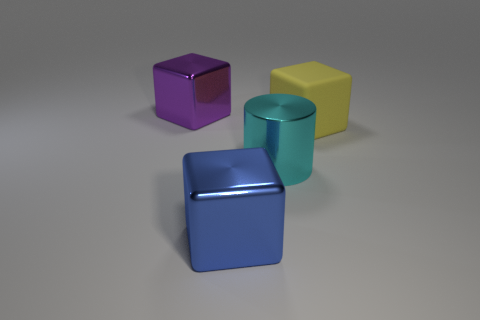Subtract all big shiny blocks. How many blocks are left? 1 Add 4 red cylinders. How many objects exist? 8 Subtract all blue cubes. How many cubes are left? 2 Subtract all cylinders. How many objects are left? 3 Add 1 cyan cylinders. How many cyan cylinders exist? 2 Subtract 0 cyan spheres. How many objects are left? 4 Subtract all green cubes. Subtract all green balls. How many cubes are left? 3 Subtract all yellow blocks. Subtract all large cyan cylinders. How many objects are left? 2 Add 2 large blue shiny blocks. How many large blue shiny blocks are left? 3 